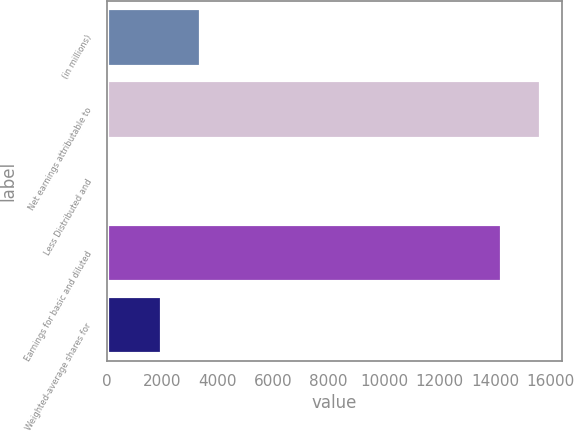Convert chart to OTSL. <chart><loc_0><loc_0><loc_500><loc_500><bar_chart><fcel>(in millions)<fcel>Net earnings attributable to<fcel>Less Distributed and<fcel>Earnings for basic and diluted<fcel>Weighted-average shares for<nl><fcel>3373.5<fcel>15636.5<fcel>24<fcel>14215<fcel>1952<nl></chart> 